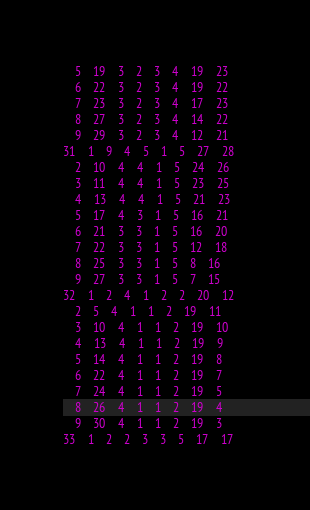Convert code to text. <code><loc_0><loc_0><loc_500><loc_500><_ObjectiveC_>	5	19	3	2	3	4	19	23	
	6	22	3	2	3	4	19	22	
	7	23	3	2	3	4	17	23	
	8	27	3	2	3	4	14	22	
	9	29	3	2	3	4	12	21	
31	1	9	4	5	1	5	27	28	
	2	10	4	4	1	5	24	26	
	3	11	4	4	1	5	23	25	
	4	13	4	4	1	5	21	23	
	5	17	4	3	1	5	16	21	
	6	21	3	3	1	5	16	20	
	7	22	3	3	1	5	12	18	
	8	25	3	3	1	5	8	16	
	9	27	3	3	1	5	7	15	
32	1	2	4	1	2	2	20	12	
	2	5	4	1	1	2	19	11	
	3	10	4	1	1	2	19	10	
	4	13	4	1	1	2	19	9	
	5	14	4	1	1	2	19	8	
	6	22	4	1	1	2	19	7	
	7	24	4	1	1	2	19	5	
	8	26	4	1	1	2	19	4	
	9	30	4	1	1	2	19	3	
33	1	2	2	3	3	5	17	17	</code> 